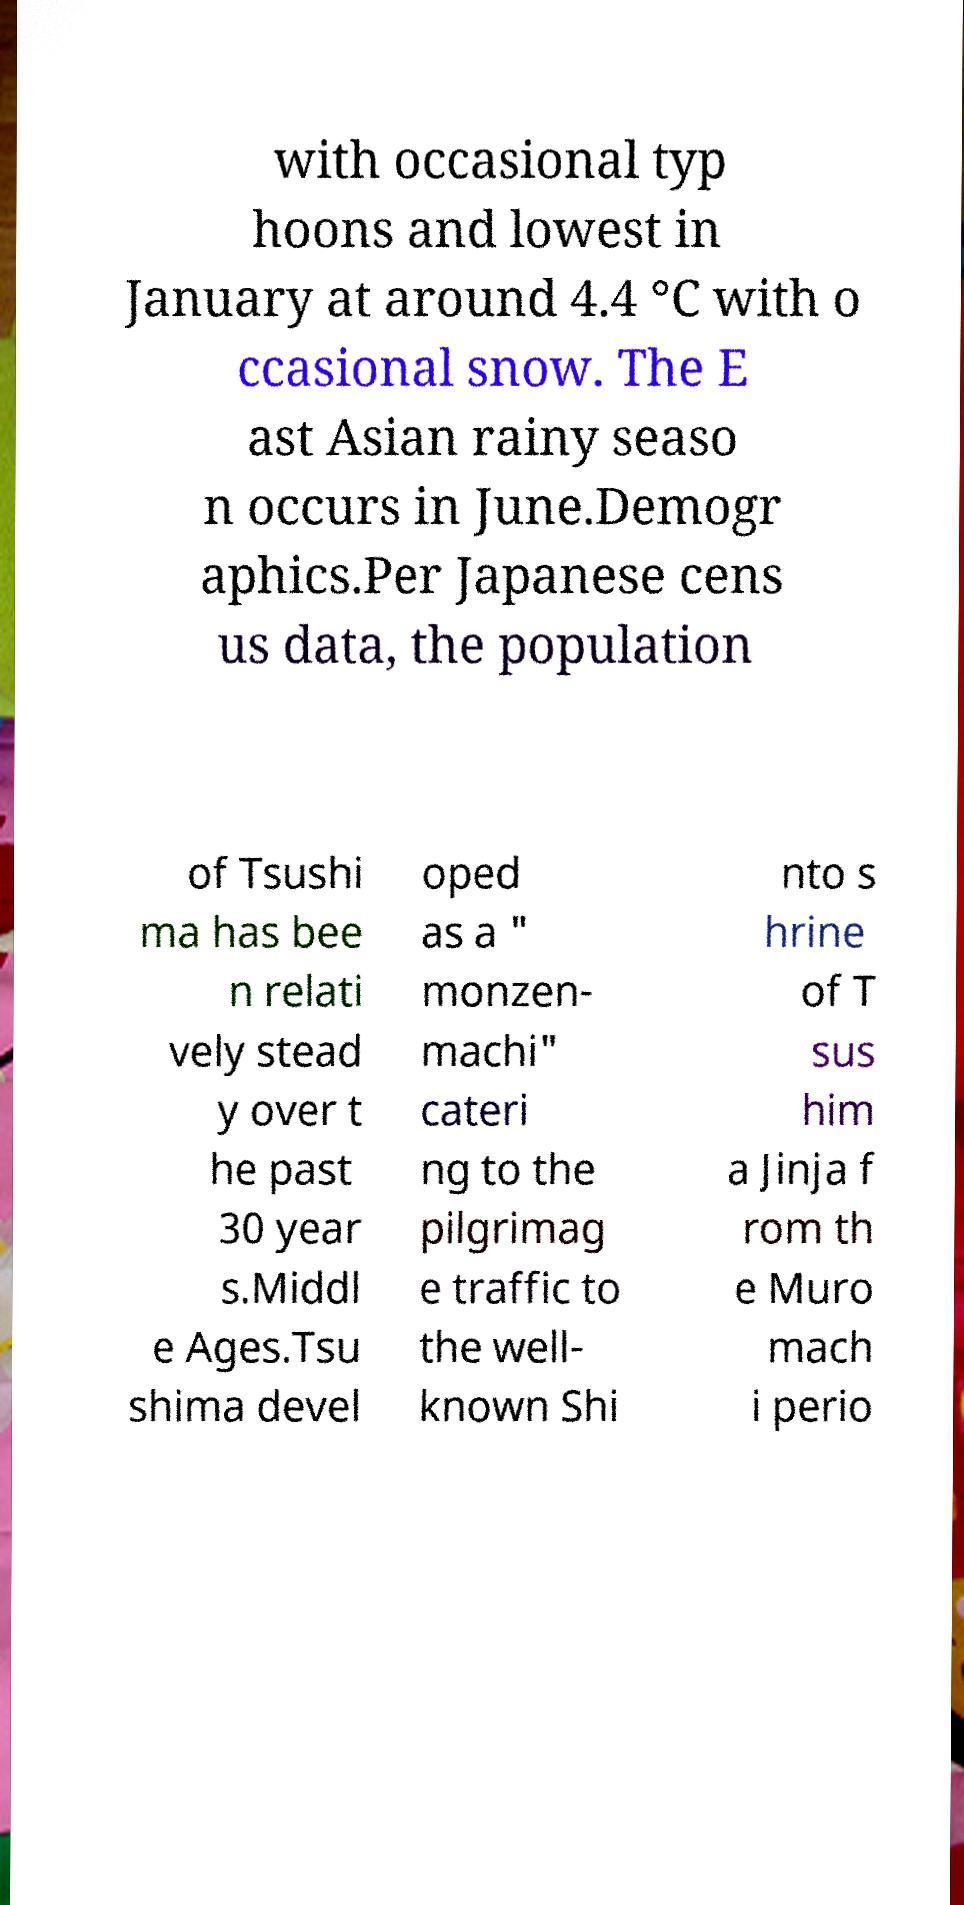For documentation purposes, I need the text within this image transcribed. Could you provide that? with occasional typ hoons and lowest in January at around 4.4 °C with o ccasional snow. The E ast Asian rainy seaso n occurs in June.Demogr aphics.Per Japanese cens us data, the population of Tsushi ma has bee n relati vely stead y over t he past 30 year s.Middl e Ages.Tsu shima devel oped as a " monzen- machi" cateri ng to the pilgrimag e traffic to the well- known Shi nto s hrine of T sus him a Jinja f rom th e Muro mach i perio 